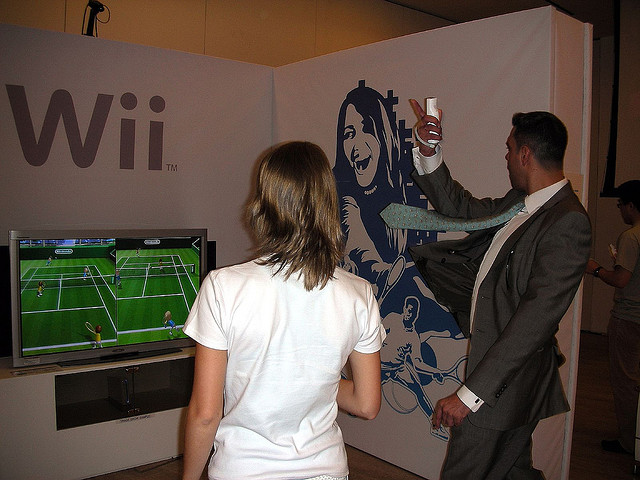<image>What is the girl's favorite team? It is unknown what the girl's favorite team is. What color is the ceiling? I am not sure about the color of the ceiling. It can be white, tan or yellow. What store is this? It's ambiguous which store this is. It can be a game store, Wii store, Nintendo or Target. What is the girl's favorite team? It is unknown what the girl's favorite team is. However, it can be seen that she might like the Orioles, Reds, Cowboys, or Braves. What color is the ceiling? I am not sure what color the ceiling is. It can be either white, tan, or yellow. What store is this? I am not sure what store it is. It can be either a game store, a Wii store, or a Target store. 